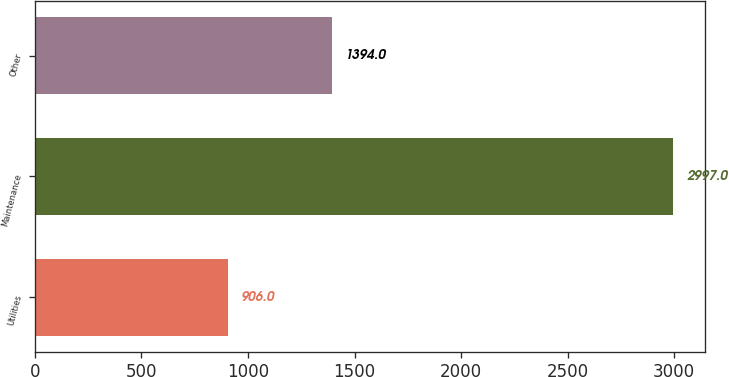<chart> <loc_0><loc_0><loc_500><loc_500><bar_chart><fcel>Utilities<fcel>Maintenance<fcel>Other<nl><fcel>906<fcel>2997<fcel>1394<nl></chart> 